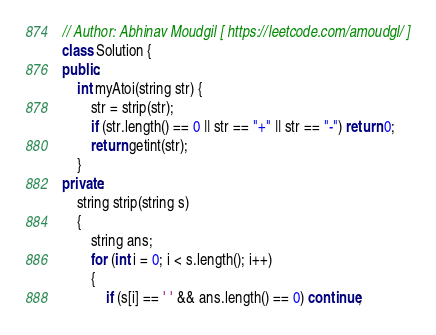Convert code to text. <code><loc_0><loc_0><loc_500><loc_500><_C++_>// Author: Abhinav Moudgil [ https://leetcode.com/amoudgl/ ]
class Solution {
public:
    int myAtoi(string str) {
        str = strip(str);
        if (str.length() == 0 || str == "+" || str == "-") return 0;
        return getint(str);
    }
private:
    string strip(string s)
    {
        string ans;
        for (int i = 0; i < s.length(); i++)
        {
            if (s[i] == ' ' && ans.length() == 0) continue;</code> 